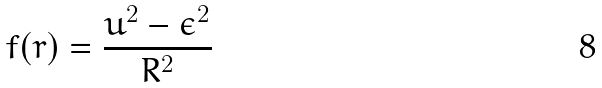<formula> <loc_0><loc_0><loc_500><loc_500>f ( r ) = \frac { u ^ { 2 } - \epsilon ^ { 2 } } { R ^ { 2 } }</formula> 